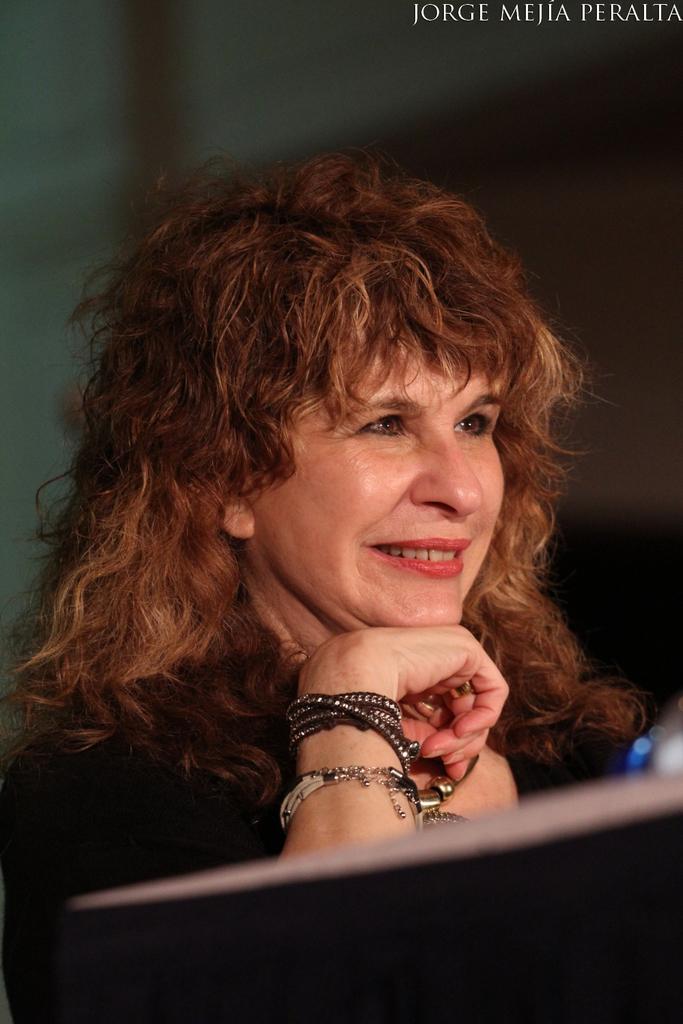How would you summarize this image in a sentence or two? In this image we can see a woman wearing dress. In the foreground we can see a table. In the background, we can see some text. 